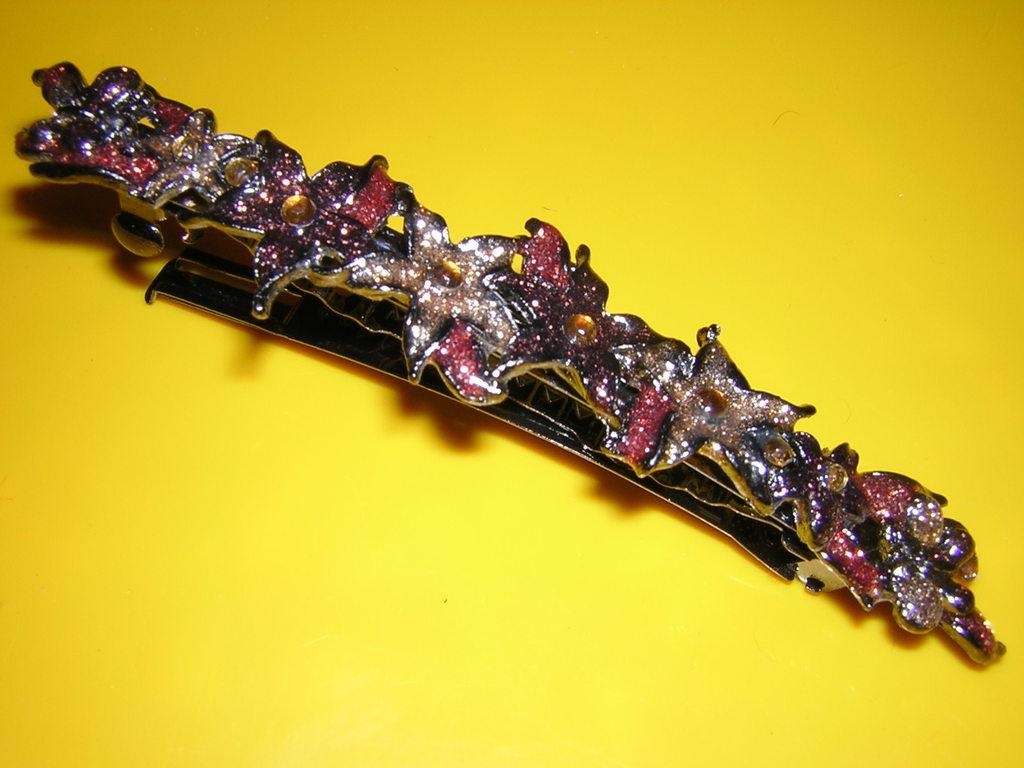What object can be seen in the picture? There is a hair clip in the picture. What is unique about the hair clip? The hair clip has designs on it. On what surface is the hair clip placed? The hair clip is placed on a yellow-colored surface. Can you see a tiger walking near the hair clip in the image? No, there is no tiger or any animal present in the image. What type of card is placed next to the hair clip? There is no card present in the image; it only features a hair clip on a yellow-colored surface. 